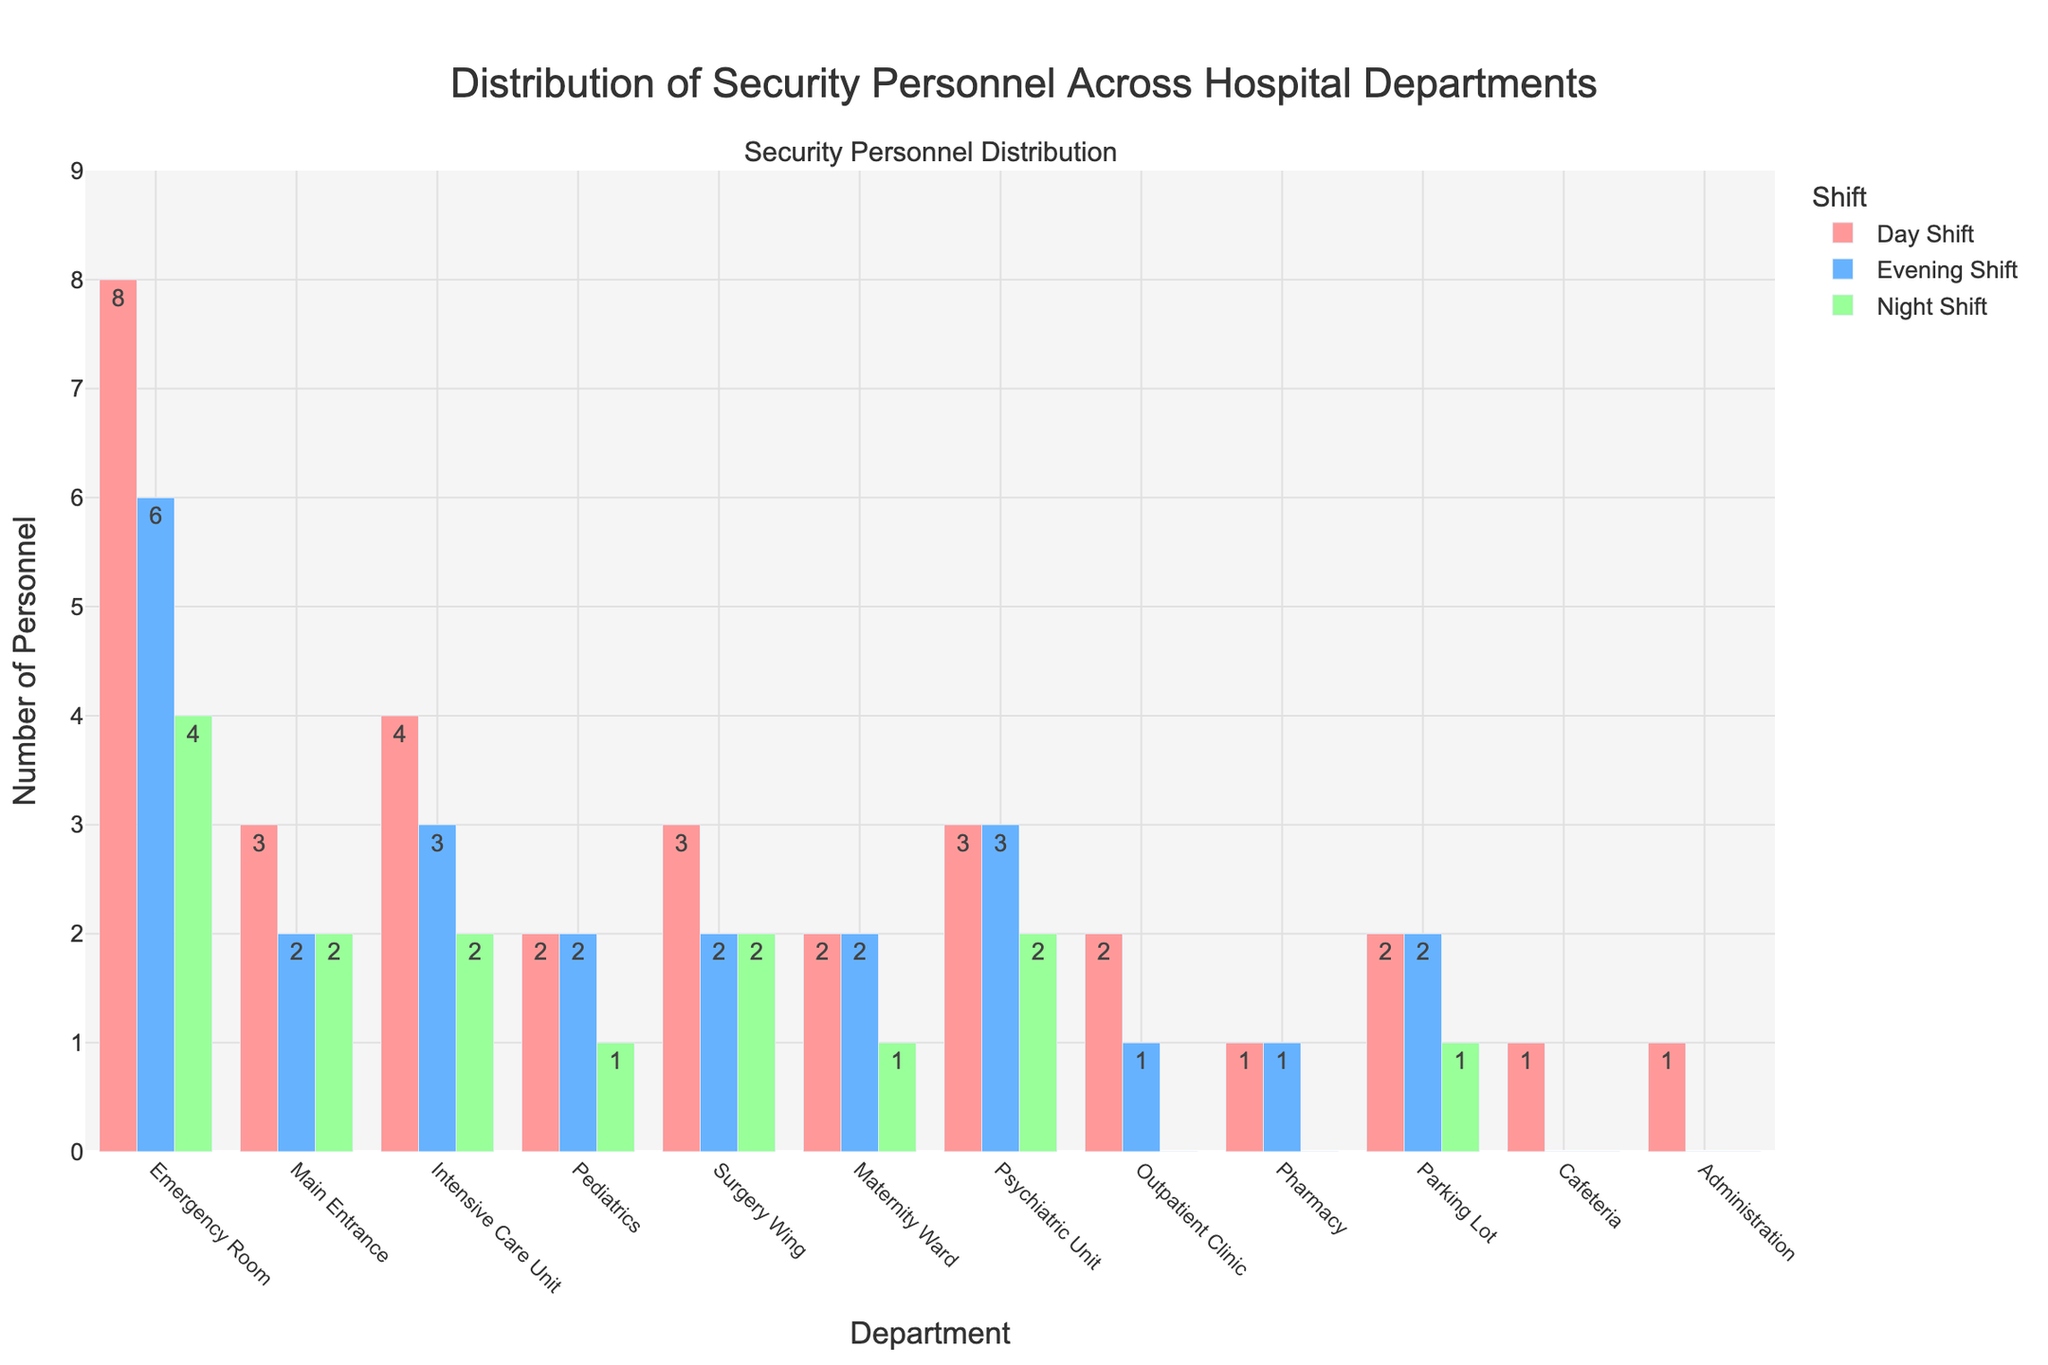Which department has the highest number of security personnel during the day shift? Look at the heights of the bars corresponding to the day shift for all departments and identify the tallest one. The Emergency Room has the tallest bar with a count of 8.
Answer: Emergency Room How many departments have no security personnel during the night shift? Look at the lengths of the bars corresponding to the night shift for all departments and count the ones with no bar. The Outpatient Clinic, Pharmacy, Cafeteria, and Administration have no bars.
Answer: 4 What is the total number of security personnel assigned to the Main Entrance across all shifts? Sum the values for the Main Entrance in the Day Shift, Evening Shift, and Night Shift. That's 3 for Day, 2 for Evening, and 2 for Night: 3 + 2 + 2 = 7.
Answer: 7 Compare the total number of security personnel in the Surgery Wing with the Maternity Ward. Which has more? Sum the total personnel for Surgery Wing (3 Day + 2 Evening + 2 Night = 7) and the Maternity Ward (2 Day + 2 Evening + 1 Night = 5). Surgery Wing has more personnel.
Answer: Surgery Wing What is the difference in the number of security personnel between the Emergency Room and Pediatrics during the evening shift? Subtract the number of security personnel in Pediatrics from those in the Emergency Room during the evening shift: 6 (Emergency Room) - 2 (Pediatrics) = 4.
Answer: 4 Which shift in the Intensive Care Unit has the least number of security personnel? Examine the heights of the bars for the Intensive Care Unit and identify the shortest one. The Night Shift has the shortest bar with a count of 2.
Answer: Night Shift How many departments have exactly 1 security personnel during the day shift? Count the bars corresponding to the day shift that have a value of 1. There are two such departments: Pharmacy and Administration.
Answer: 2 What is the average number of security personnel during the night shift across all departments? Sum up the personnel counts during the night shift for all departments and divide by the total number of departments (12). Sum = 4 (ER) + 2 (Main) + 2 (ICU) + 1 (Peds) + 2 (Surgery) + 1 (Mat) + 2 (Psych) + 0 (Out) + 0 (Phar) + 1 (Park) + 0 (Cafe) + 0 (Admin) = 15. 15 / 12 ≈ 1.25.
Answer: 1.25 Which department has equal numbers of security personnel across all shifts? Look for bars of equal height across all shifts for any department. None of the departments meet this criterion.
Answer: None Is the total number of security personnel in Pediatrics greater than that in the Intensive Care Unit? Sum the total personnel in Pediatrics (2 Day + 2 Evening + 1 Night = 5) and in the Intensive Care Unit (4 Day + 3 Evening + 2 Night = 9). Compare the sums; the Intensive Care Unit has more personnel.
Answer: No 